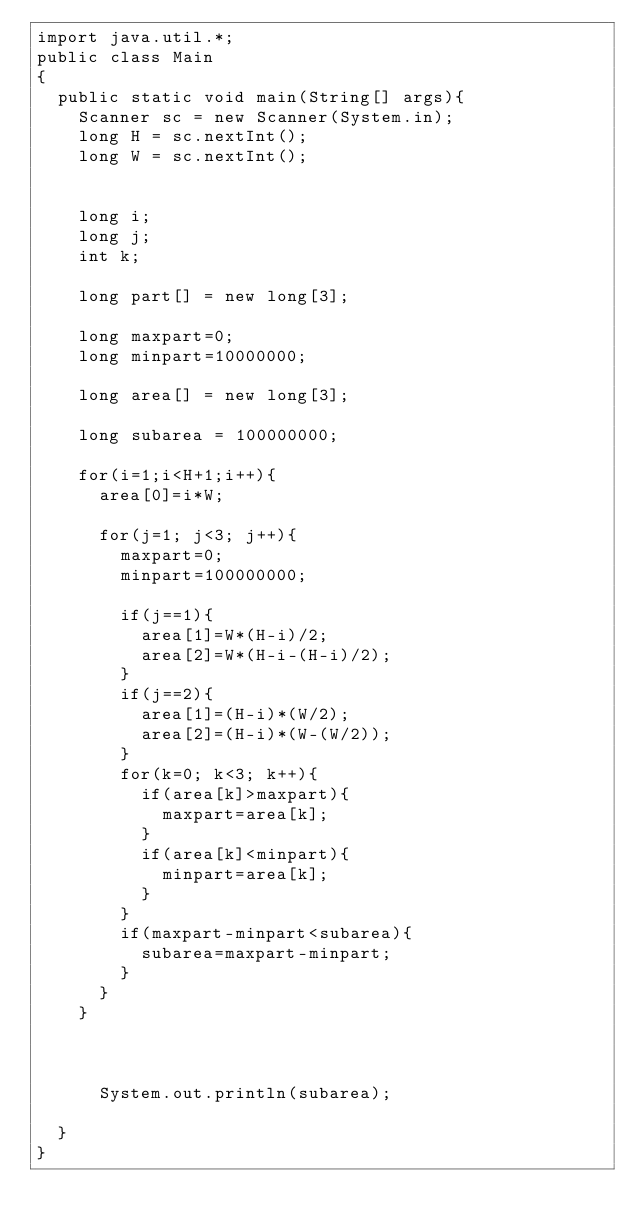Convert code to text. <code><loc_0><loc_0><loc_500><loc_500><_Java_>import java.util.*;
public class Main
{
	public static void main(String[] args){
		Scanner sc = new Scanner(System.in);
		long H = sc.nextInt();
		long W = sc.nextInt();
		
		
		long i;
		long j;
		int k;
		
		long part[] = new long[3];
		
		long maxpart=0;
		long minpart=10000000;
		
		long area[] = new long[3];
		
		long subarea = 100000000;
		
		for(i=1;i<H+1;i++){
			area[0]=i*W;
			
			for(j=1; j<3; j++){
				maxpart=0;
				minpart=100000000;
				
				if(j==1){
					area[1]=W*(H-i)/2;
					area[2]=W*(H-i-(H-i)/2);
				}
				if(j==2){
					area[1]=(H-i)*(W/2);
					area[2]=(H-i)*(W-(W/2));
				}
				for(k=0; k<3; k++){
					if(area[k]>maxpart){
						maxpart=area[k];
					}
					if(area[k]<minpart){
						minpart=area[k];
					}
				}
				if(maxpart-minpart<subarea){
					subarea=maxpart-minpart;
				}			
			}
		}
		

		
			System.out.println(subarea);

	}
}</code> 